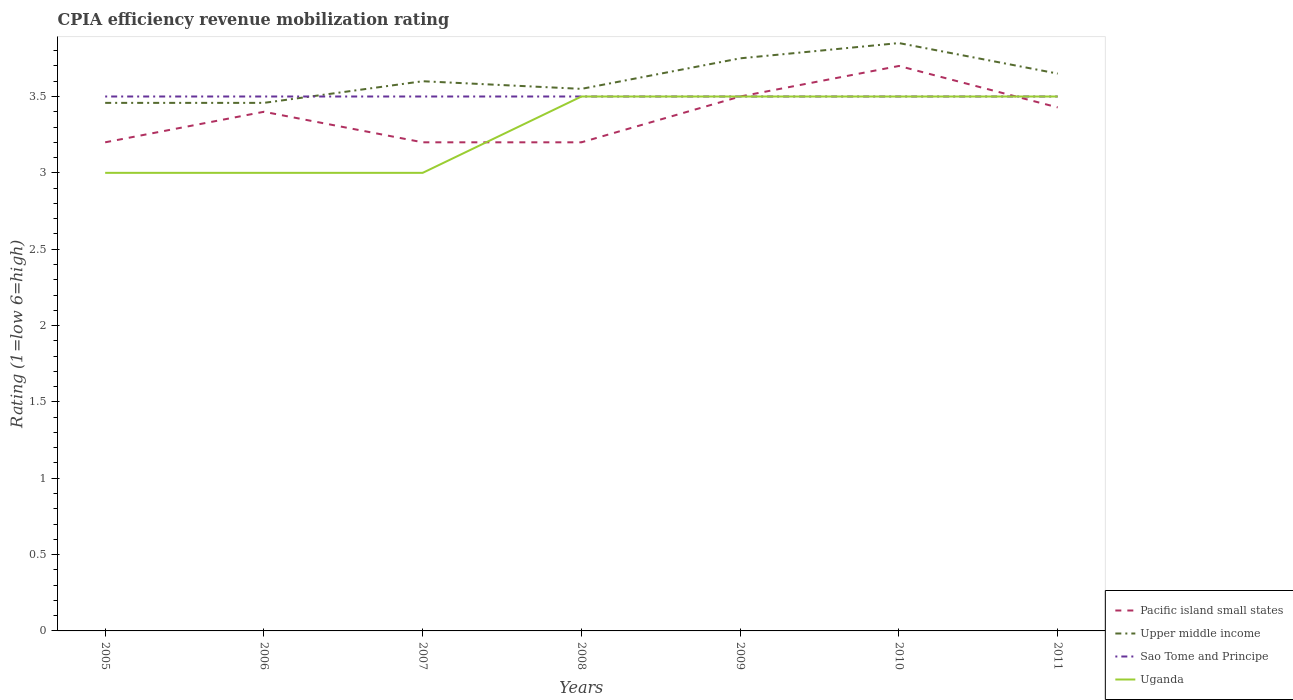Does the line corresponding to Uganda intersect with the line corresponding to Sao Tome and Principe?
Your answer should be compact. Yes. Is the number of lines equal to the number of legend labels?
Offer a very short reply. Yes. Across all years, what is the maximum CPIA rating in Upper middle income?
Provide a succinct answer. 3.46. In which year was the CPIA rating in Uganda maximum?
Your answer should be compact. 2005. What is the total CPIA rating in Sao Tome and Principe in the graph?
Offer a very short reply. 0. What is the difference between the highest and the second highest CPIA rating in Sao Tome and Principe?
Give a very brief answer. 0. Is the CPIA rating in Upper middle income strictly greater than the CPIA rating in Uganda over the years?
Ensure brevity in your answer.  No. How many lines are there?
Your response must be concise. 4. How many years are there in the graph?
Keep it short and to the point. 7. How many legend labels are there?
Give a very brief answer. 4. What is the title of the graph?
Make the answer very short. CPIA efficiency revenue mobilization rating. What is the label or title of the Y-axis?
Your answer should be very brief. Rating (1=low 6=high). What is the Rating (1=low 6=high) in Pacific island small states in 2005?
Provide a short and direct response. 3.2. What is the Rating (1=low 6=high) of Upper middle income in 2005?
Ensure brevity in your answer.  3.46. What is the Rating (1=low 6=high) in Upper middle income in 2006?
Your response must be concise. 3.46. What is the Rating (1=low 6=high) in Sao Tome and Principe in 2006?
Offer a very short reply. 3.5. What is the Rating (1=low 6=high) in Pacific island small states in 2007?
Offer a very short reply. 3.2. What is the Rating (1=low 6=high) in Sao Tome and Principe in 2007?
Ensure brevity in your answer.  3.5. What is the Rating (1=low 6=high) of Pacific island small states in 2008?
Give a very brief answer. 3.2. What is the Rating (1=low 6=high) in Upper middle income in 2008?
Keep it short and to the point. 3.55. What is the Rating (1=low 6=high) in Uganda in 2008?
Offer a very short reply. 3.5. What is the Rating (1=low 6=high) in Upper middle income in 2009?
Make the answer very short. 3.75. What is the Rating (1=low 6=high) of Sao Tome and Principe in 2009?
Give a very brief answer. 3.5. What is the Rating (1=low 6=high) of Upper middle income in 2010?
Offer a terse response. 3.85. What is the Rating (1=low 6=high) in Sao Tome and Principe in 2010?
Ensure brevity in your answer.  3.5. What is the Rating (1=low 6=high) of Pacific island small states in 2011?
Make the answer very short. 3.43. What is the Rating (1=low 6=high) of Upper middle income in 2011?
Keep it short and to the point. 3.65. What is the Rating (1=low 6=high) in Sao Tome and Principe in 2011?
Give a very brief answer. 3.5. What is the Rating (1=low 6=high) of Uganda in 2011?
Your answer should be very brief. 3.5. Across all years, what is the maximum Rating (1=low 6=high) of Upper middle income?
Offer a very short reply. 3.85. Across all years, what is the minimum Rating (1=low 6=high) in Pacific island small states?
Offer a very short reply. 3.2. Across all years, what is the minimum Rating (1=low 6=high) in Upper middle income?
Provide a short and direct response. 3.46. What is the total Rating (1=low 6=high) in Pacific island small states in the graph?
Offer a very short reply. 23.63. What is the total Rating (1=low 6=high) in Upper middle income in the graph?
Ensure brevity in your answer.  25.32. What is the total Rating (1=low 6=high) in Sao Tome and Principe in the graph?
Offer a very short reply. 24.5. What is the total Rating (1=low 6=high) of Uganda in the graph?
Your answer should be compact. 23. What is the difference between the Rating (1=low 6=high) in Upper middle income in 2005 and that in 2006?
Give a very brief answer. 0. What is the difference between the Rating (1=low 6=high) in Upper middle income in 2005 and that in 2007?
Offer a terse response. -0.14. What is the difference between the Rating (1=low 6=high) in Upper middle income in 2005 and that in 2008?
Make the answer very short. -0.09. What is the difference between the Rating (1=low 6=high) in Uganda in 2005 and that in 2008?
Make the answer very short. -0.5. What is the difference between the Rating (1=low 6=high) of Pacific island small states in 2005 and that in 2009?
Provide a short and direct response. -0.3. What is the difference between the Rating (1=low 6=high) in Upper middle income in 2005 and that in 2009?
Your answer should be compact. -0.29. What is the difference between the Rating (1=low 6=high) of Upper middle income in 2005 and that in 2010?
Your answer should be compact. -0.39. What is the difference between the Rating (1=low 6=high) in Sao Tome and Principe in 2005 and that in 2010?
Make the answer very short. 0. What is the difference between the Rating (1=low 6=high) of Pacific island small states in 2005 and that in 2011?
Give a very brief answer. -0.23. What is the difference between the Rating (1=low 6=high) in Upper middle income in 2005 and that in 2011?
Your answer should be very brief. -0.19. What is the difference between the Rating (1=low 6=high) in Upper middle income in 2006 and that in 2007?
Offer a very short reply. -0.14. What is the difference between the Rating (1=low 6=high) of Sao Tome and Principe in 2006 and that in 2007?
Keep it short and to the point. 0. What is the difference between the Rating (1=low 6=high) of Uganda in 2006 and that in 2007?
Offer a terse response. 0. What is the difference between the Rating (1=low 6=high) of Pacific island small states in 2006 and that in 2008?
Provide a succinct answer. 0.2. What is the difference between the Rating (1=low 6=high) in Upper middle income in 2006 and that in 2008?
Ensure brevity in your answer.  -0.09. What is the difference between the Rating (1=low 6=high) of Sao Tome and Principe in 2006 and that in 2008?
Offer a terse response. 0. What is the difference between the Rating (1=low 6=high) in Upper middle income in 2006 and that in 2009?
Your response must be concise. -0.29. What is the difference between the Rating (1=low 6=high) in Sao Tome and Principe in 2006 and that in 2009?
Your answer should be very brief. 0. What is the difference between the Rating (1=low 6=high) of Uganda in 2006 and that in 2009?
Your response must be concise. -0.5. What is the difference between the Rating (1=low 6=high) in Pacific island small states in 2006 and that in 2010?
Offer a very short reply. -0.3. What is the difference between the Rating (1=low 6=high) of Upper middle income in 2006 and that in 2010?
Offer a very short reply. -0.39. What is the difference between the Rating (1=low 6=high) in Sao Tome and Principe in 2006 and that in 2010?
Keep it short and to the point. 0. What is the difference between the Rating (1=low 6=high) in Uganda in 2006 and that in 2010?
Your response must be concise. -0.5. What is the difference between the Rating (1=low 6=high) of Pacific island small states in 2006 and that in 2011?
Ensure brevity in your answer.  -0.03. What is the difference between the Rating (1=low 6=high) of Upper middle income in 2006 and that in 2011?
Make the answer very short. -0.19. What is the difference between the Rating (1=low 6=high) of Sao Tome and Principe in 2006 and that in 2011?
Make the answer very short. 0. What is the difference between the Rating (1=low 6=high) in Pacific island small states in 2007 and that in 2009?
Make the answer very short. -0.3. What is the difference between the Rating (1=low 6=high) in Upper middle income in 2007 and that in 2009?
Make the answer very short. -0.15. What is the difference between the Rating (1=low 6=high) of Pacific island small states in 2007 and that in 2010?
Ensure brevity in your answer.  -0.5. What is the difference between the Rating (1=low 6=high) in Uganda in 2007 and that in 2010?
Ensure brevity in your answer.  -0.5. What is the difference between the Rating (1=low 6=high) in Pacific island small states in 2007 and that in 2011?
Keep it short and to the point. -0.23. What is the difference between the Rating (1=low 6=high) in Sao Tome and Principe in 2007 and that in 2011?
Provide a short and direct response. 0. What is the difference between the Rating (1=low 6=high) in Upper middle income in 2008 and that in 2009?
Provide a succinct answer. -0.2. What is the difference between the Rating (1=low 6=high) in Sao Tome and Principe in 2008 and that in 2009?
Your answer should be very brief. 0. What is the difference between the Rating (1=low 6=high) in Uganda in 2008 and that in 2009?
Provide a succinct answer. 0. What is the difference between the Rating (1=low 6=high) in Pacific island small states in 2008 and that in 2010?
Keep it short and to the point. -0.5. What is the difference between the Rating (1=low 6=high) in Sao Tome and Principe in 2008 and that in 2010?
Provide a short and direct response. 0. What is the difference between the Rating (1=low 6=high) in Pacific island small states in 2008 and that in 2011?
Make the answer very short. -0.23. What is the difference between the Rating (1=low 6=high) in Sao Tome and Principe in 2008 and that in 2011?
Your response must be concise. 0. What is the difference between the Rating (1=low 6=high) of Uganda in 2008 and that in 2011?
Provide a succinct answer. 0. What is the difference between the Rating (1=low 6=high) in Pacific island small states in 2009 and that in 2010?
Offer a terse response. -0.2. What is the difference between the Rating (1=low 6=high) of Sao Tome and Principe in 2009 and that in 2010?
Ensure brevity in your answer.  0. What is the difference between the Rating (1=low 6=high) in Pacific island small states in 2009 and that in 2011?
Offer a terse response. 0.07. What is the difference between the Rating (1=low 6=high) of Upper middle income in 2009 and that in 2011?
Offer a very short reply. 0.1. What is the difference between the Rating (1=low 6=high) in Sao Tome and Principe in 2009 and that in 2011?
Offer a terse response. 0. What is the difference between the Rating (1=low 6=high) of Pacific island small states in 2010 and that in 2011?
Give a very brief answer. 0.27. What is the difference between the Rating (1=low 6=high) of Upper middle income in 2010 and that in 2011?
Give a very brief answer. 0.2. What is the difference between the Rating (1=low 6=high) of Sao Tome and Principe in 2010 and that in 2011?
Offer a very short reply. 0. What is the difference between the Rating (1=low 6=high) of Pacific island small states in 2005 and the Rating (1=low 6=high) of Upper middle income in 2006?
Ensure brevity in your answer.  -0.26. What is the difference between the Rating (1=low 6=high) in Upper middle income in 2005 and the Rating (1=low 6=high) in Sao Tome and Principe in 2006?
Offer a terse response. -0.04. What is the difference between the Rating (1=low 6=high) of Upper middle income in 2005 and the Rating (1=low 6=high) of Uganda in 2006?
Ensure brevity in your answer.  0.46. What is the difference between the Rating (1=low 6=high) of Sao Tome and Principe in 2005 and the Rating (1=low 6=high) of Uganda in 2006?
Keep it short and to the point. 0.5. What is the difference between the Rating (1=low 6=high) of Pacific island small states in 2005 and the Rating (1=low 6=high) of Upper middle income in 2007?
Offer a terse response. -0.4. What is the difference between the Rating (1=low 6=high) in Pacific island small states in 2005 and the Rating (1=low 6=high) in Sao Tome and Principe in 2007?
Keep it short and to the point. -0.3. What is the difference between the Rating (1=low 6=high) in Upper middle income in 2005 and the Rating (1=low 6=high) in Sao Tome and Principe in 2007?
Provide a short and direct response. -0.04. What is the difference between the Rating (1=low 6=high) in Upper middle income in 2005 and the Rating (1=low 6=high) in Uganda in 2007?
Make the answer very short. 0.46. What is the difference between the Rating (1=low 6=high) of Pacific island small states in 2005 and the Rating (1=low 6=high) of Upper middle income in 2008?
Provide a short and direct response. -0.35. What is the difference between the Rating (1=low 6=high) of Upper middle income in 2005 and the Rating (1=low 6=high) of Sao Tome and Principe in 2008?
Provide a short and direct response. -0.04. What is the difference between the Rating (1=low 6=high) of Upper middle income in 2005 and the Rating (1=low 6=high) of Uganda in 2008?
Provide a short and direct response. -0.04. What is the difference between the Rating (1=low 6=high) of Pacific island small states in 2005 and the Rating (1=low 6=high) of Upper middle income in 2009?
Your response must be concise. -0.55. What is the difference between the Rating (1=low 6=high) of Pacific island small states in 2005 and the Rating (1=low 6=high) of Sao Tome and Principe in 2009?
Your answer should be very brief. -0.3. What is the difference between the Rating (1=low 6=high) of Upper middle income in 2005 and the Rating (1=low 6=high) of Sao Tome and Principe in 2009?
Give a very brief answer. -0.04. What is the difference between the Rating (1=low 6=high) of Upper middle income in 2005 and the Rating (1=low 6=high) of Uganda in 2009?
Provide a succinct answer. -0.04. What is the difference between the Rating (1=low 6=high) in Pacific island small states in 2005 and the Rating (1=low 6=high) in Upper middle income in 2010?
Your response must be concise. -0.65. What is the difference between the Rating (1=low 6=high) in Pacific island small states in 2005 and the Rating (1=low 6=high) in Uganda in 2010?
Offer a terse response. -0.3. What is the difference between the Rating (1=low 6=high) of Upper middle income in 2005 and the Rating (1=low 6=high) of Sao Tome and Principe in 2010?
Give a very brief answer. -0.04. What is the difference between the Rating (1=low 6=high) of Upper middle income in 2005 and the Rating (1=low 6=high) of Uganda in 2010?
Your answer should be very brief. -0.04. What is the difference between the Rating (1=low 6=high) of Sao Tome and Principe in 2005 and the Rating (1=low 6=high) of Uganda in 2010?
Your response must be concise. 0. What is the difference between the Rating (1=low 6=high) of Pacific island small states in 2005 and the Rating (1=low 6=high) of Upper middle income in 2011?
Provide a succinct answer. -0.45. What is the difference between the Rating (1=low 6=high) of Pacific island small states in 2005 and the Rating (1=low 6=high) of Sao Tome and Principe in 2011?
Provide a succinct answer. -0.3. What is the difference between the Rating (1=low 6=high) of Upper middle income in 2005 and the Rating (1=low 6=high) of Sao Tome and Principe in 2011?
Your answer should be compact. -0.04. What is the difference between the Rating (1=low 6=high) in Upper middle income in 2005 and the Rating (1=low 6=high) in Uganda in 2011?
Give a very brief answer. -0.04. What is the difference between the Rating (1=low 6=high) in Sao Tome and Principe in 2005 and the Rating (1=low 6=high) in Uganda in 2011?
Give a very brief answer. 0. What is the difference between the Rating (1=low 6=high) of Pacific island small states in 2006 and the Rating (1=low 6=high) of Sao Tome and Principe in 2007?
Your answer should be very brief. -0.1. What is the difference between the Rating (1=low 6=high) in Upper middle income in 2006 and the Rating (1=low 6=high) in Sao Tome and Principe in 2007?
Keep it short and to the point. -0.04. What is the difference between the Rating (1=low 6=high) in Upper middle income in 2006 and the Rating (1=low 6=high) in Uganda in 2007?
Provide a short and direct response. 0.46. What is the difference between the Rating (1=low 6=high) of Sao Tome and Principe in 2006 and the Rating (1=low 6=high) of Uganda in 2007?
Your answer should be compact. 0.5. What is the difference between the Rating (1=low 6=high) of Upper middle income in 2006 and the Rating (1=low 6=high) of Sao Tome and Principe in 2008?
Your answer should be compact. -0.04. What is the difference between the Rating (1=low 6=high) of Upper middle income in 2006 and the Rating (1=low 6=high) of Uganda in 2008?
Your response must be concise. -0.04. What is the difference between the Rating (1=low 6=high) of Sao Tome and Principe in 2006 and the Rating (1=low 6=high) of Uganda in 2008?
Your response must be concise. 0. What is the difference between the Rating (1=low 6=high) of Pacific island small states in 2006 and the Rating (1=low 6=high) of Upper middle income in 2009?
Ensure brevity in your answer.  -0.35. What is the difference between the Rating (1=low 6=high) of Pacific island small states in 2006 and the Rating (1=low 6=high) of Uganda in 2009?
Provide a short and direct response. -0.1. What is the difference between the Rating (1=low 6=high) in Upper middle income in 2006 and the Rating (1=low 6=high) in Sao Tome and Principe in 2009?
Offer a very short reply. -0.04. What is the difference between the Rating (1=low 6=high) in Upper middle income in 2006 and the Rating (1=low 6=high) in Uganda in 2009?
Your response must be concise. -0.04. What is the difference between the Rating (1=low 6=high) in Sao Tome and Principe in 2006 and the Rating (1=low 6=high) in Uganda in 2009?
Your answer should be compact. 0. What is the difference between the Rating (1=low 6=high) of Pacific island small states in 2006 and the Rating (1=low 6=high) of Upper middle income in 2010?
Your response must be concise. -0.45. What is the difference between the Rating (1=low 6=high) in Pacific island small states in 2006 and the Rating (1=low 6=high) in Sao Tome and Principe in 2010?
Provide a succinct answer. -0.1. What is the difference between the Rating (1=low 6=high) of Pacific island small states in 2006 and the Rating (1=low 6=high) of Uganda in 2010?
Provide a succinct answer. -0.1. What is the difference between the Rating (1=low 6=high) of Upper middle income in 2006 and the Rating (1=low 6=high) of Sao Tome and Principe in 2010?
Provide a succinct answer. -0.04. What is the difference between the Rating (1=low 6=high) of Upper middle income in 2006 and the Rating (1=low 6=high) of Uganda in 2010?
Keep it short and to the point. -0.04. What is the difference between the Rating (1=low 6=high) in Pacific island small states in 2006 and the Rating (1=low 6=high) in Uganda in 2011?
Give a very brief answer. -0.1. What is the difference between the Rating (1=low 6=high) in Upper middle income in 2006 and the Rating (1=low 6=high) in Sao Tome and Principe in 2011?
Provide a succinct answer. -0.04. What is the difference between the Rating (1=low 6=high) of Upper middle income in 2006 and the Rating (1=low 6=high) of Uganda in 2011?
Give a very brief answer. -0.04. What is the difference between the Rating (1=low 6=high) in Pacific island small states in 2007 and the Rating (1=low 6=high) in Upper middle income in 2008?
Make the answer very short. -0.35. What is the difference between the Rating (1=low 6=high) in Pacific island small states in 2007 and the Rating (1=low 6=high) in Sao Tome and Principe in 2008?
Give a very brief answer. -0.3. What is the difference between the Rating (1=low 6=high) in Upper middle income in 2007 and the Rating (1=low 6=high) in Sao Tome and Principe in 2008?
Your answer should be very brief. 0.1. What is the difference between the Rating (1=low 6=high) in Upper middle income in 2007 and the Rating (1=low 6=high) in Uganda in 2008?
Your answer should be compact. 0.1. What is the difference between the Rating (1=low 6=high) in Sao Tome and Principe in 2007 and the Rating (1=low 6=high) in Uganda in 2008?
Your response must be concise. 0. What is the difference between the Rating (1=low 6=high) of Pacific island small states in 2007 and the Rating (1=low 6=high) of Upper middle income in 2009?
Your answer should be compact. -0.55. What is the difference between the Rating (1=low 6=high) in Pacific island small states in 2007 and the Rating (1=low 6=high) in Upper middle income in 2010?
Provide a succinct answer. -0.65. What is the difference between the Rating (1=low 6=high) of Upper middle income in 2007 and the Rating (1=low 6=high) of Sao Tome and Principe in 2010?
Offer a very short reply. 0.1. What is the difference between the Rating (1=low 6=high) in Upper middle income in 2007 and the Rating (1=low 6=high) in Uganda in 2010?
Make the answer very short. 0.1. What is the difference between the Rating (1=low 6=high) of Pacific island small states in 2007 and the Rating (1=low 6=high) of Upper middle income in 2011?
Offer a terse response. -0.45. What is the difference between the Rating (1=low 6=high) of Pacific island small states in 2007 and the Rating (1=low 6=high) of Sao Tome and Principe in 2011?
Make the answer very short. -0.3. What is the difference between the Rating (1=low 6=high) in Sao Tome and Principe in 2007 and the Rating (1=low 6=high) in Uganda in 2011?
Make the answer very short. 0. What is the difference between the Rating (1=low 6=high) in Pacific island small states in 2008 and the Rating (1=low 6=high) in Upper middle income in 2009?
Make the answer very short. -0.55. What is the difference between the Rating (1=low 6=high) of Pacific island small states in 2008 and the Rating (1=low 6=high) of Sao Tome and Principe in 2009?
Keep it short and to the point. -0.3. What is the difference between the Rating (1=low 6=high) of Upper middle income in 2008 and the Rating (1=low 6=high) of Sao Tome and Principe in 2009?
Offer a terse response. 0.05. What is the difference between the Rating (1=low 6=high) of Upper middle income in 2008 and the Rating (1=low 6=high) of Uganda in 2009?
Ensure brevity in your answer.  0.05. What is the difference between the Rating (1=low 6=high) in Sao Tome and Principe in 2008 and the Rating (1=low 6=high) in Uganda in 2009?
Your response must be concise. 0. What is the difference between the Rating (1=low 6=high) in Pacific island small states in 2008 and the Rating (1=low 6=high) in Upper middle income in 2010?
Ensure brevity in your answer.  -0.65. What is the difference between the Rating (1=low 6=high) of Pacific island small states in 2008 and the Rating (1=low 6=high) of Sao Tome and Principe in 2010?
Provide a succinct answer. -0.3. What is the difference between the Rating (1=low 6=high) in Pacific island small states in 2008 and the Rating (1=low 6=high) in Upper middle income in 2011?
Your answer should be compact. -0.45. What is the difference between the Rating (1=low 6=high) of Pacific island small states in 2008 and the Rating (1=low 6=high) of Sao Tome and Principe in 2011?
Make the answer very short. -0.3. What is the difference between the Rating (1=low 6=high) in Pacific island small states in 2008 and the Rating (1=low 6=high) in Uganda in 2011?
Your answer should be compact. -0.3. What is the difference between the Rating (1=low 6=high) of Pacific island small states in 2009 and the Rating (1=low 6=high) of Upper middle income in 2010?
Keep it short and to the point. -0.35. What is the difference between the Rating (1=low 6=high) of Pacific island small states in 2009 and the Rating (1=low 6=high) of Uganda in 2010?
Keep it short and to the point. 0. What is the difference between the Rating (1=low 6=high) of Upper middle income in 2009 and the Rating (1=low 6=high) of Uganda in 2010?
Your response must be concise. 0.25. What is the difference between the Rating (1=low 6=high) of Pacific island small states in 2009 and the Rating (1=low 6=high) of Upper middle income in 2011?
Your response must be concise. -0.15. What is the difference between the Rating (1=low 6=high) of Pacific island small states in 2009 and the Rating (1=low 6=high) of Sao Tome and Principe in 2011?
Provide a short and direct response. 0. What is the difference between the Rating (1=low 6=high) in Pacific island small states in 2009 and the Rating (1=low 6=high) in Uganda in 2011?
Offer a terse response. 0. What is the difference between the Rating (1=low 6=high) in Pacific island small states in 2010 and the Rating (1=low 6=high) in Upper middle income in 2011?
Provide a short and direct response. 0.05. What is the average Rating (1=low 6=high) in Pacific island small states per year?
Make the answer very short. 3.38. What is the average Rating (1=low 6=high) in Upper middle income per year?
Provide a succinct answer. 3.62. What is the average Rating (1=low 6=high) of Sao Tome and Principe per year?
Give a very brief answer. 3.5. What is the average Rating (1=low 6=high) of Uganda per year?
Your answer should be compact. 3.29. In the year 2005, what is the difference between the Rating (1=low 6=high) in Pacific island small states and Rating (1=low 6=high) in Upper middle income?
Your response must be concise. -0.26. In the year 2005, what is the difference between the Rating (1=low 6=high) in Pacific island small states and Rating (1=low 6=high) in Uganda?
Make the answer very short. 0.2. In the year 2005, what is the difference between the Rating (1=low 6=high) of Upper middle income and Rating (1=low 6=high) of Sao Tome and Principe?
Keep it short and to the point. -0.04. In the year 2005, what is the difference between the Rating (1=low 6=high) of Upper middle income and Rating (1=low 6=high) of Uganda?
Keep it short and to the point. 0.46. In the year 2005, what is the difference between the Rating (1=low 6=high) in Sao Tome and Principe and Rating (1=low 6=high) in Uganda?
Keep it short and to the point. 0.5. In the year 2006, what is the difference between the Rating (1=low 6=high) in Pacific island small states and Rating (1=low 6=high) in Upper middle income?
Give a very brief answer. -0.06. In the year 2006, what is the difference between the Rating (1=low 6=high) of Upper middle income and Rating (1=low 6=high) of Sao Tome and Principe?
Keep it short and to the point. -0.04. In the year 2006, what is the difference between the Rating (1=low 6=high) of Upper middle income and Rating (1=low 6=high) of Uganda?
Provide a succinct answer. 0.46. In the year 2007, what is the difference between the Rating (1=low 6=high) of Pacific island small states and Rating (1=low 6=high) of Sao Tome and Principe?
Offer a terse response. -0.3. In the year 2007, what is the difference between the Rating (1=low 6=high) in Pacific island small states and Rating (1=low 6=high) in Uganda?
Offer a very short reply. 0.2. In the year 2007, what is the difference between the Rating (1=low 6=high) in Upper middle income and Rating (1=low 6=high) in Sao Tome and Principe?
Keep it short and to the point. 0.1. In the year 2008, what is the difference between the Rating (1=low 6=high) of Pacific island small states and Rating (1=low 6=high) of Upper middle income?
Provide a short and direct response. -0.35. In the year 2008, what is the difference between the Rating (1=low 6=high) in Pacific island small states and Rating (1=low 6=high) in Uganda?
Keep it short and to the point. -0.3. In the year 2008, what is the difference between the Rating (1=low 6=high) of Upper middle income and Rating (1=low 6=high) of Uganda?
Your answer should be very brief. 0.05. In the year 2008, what is the difference between the Rating (1=low 6=high) in Sao Tome and Principe and Rating (1=low 6=high) in Uganda?
Make the answer very short. 0. In the year 2009, what is the difference between the Rating (1=low 6=high) of Pacific island small states and Rating (1=low 6=high) of Upper middle income?
Provide a succinct answer. -0.25. In the year 2009, what is the difference between the Rating (1=low 6=high) in Sao Tome and Principe and Rating (1=low 6=high) in Uganda?
Keep it short and to the point. 0. In the year 2010, what is the difference between the Rating (1=low 6=high) in Pacific island small states and Rating (1=low 6=high) in Upper middle income?
Ensure brevity in your answer.  -0.15. In the year 2010, what is the difference between the Rating (1=low 6=high) in Pacific island small states and Rating (1=low 6=high) in Sao Tome and Principe?
Keep it short and to the point. 0.2. In the year 2010, what is the difference between the Rating (1=low 6=high) in Upper middle income and Rating (1=low 6=high) in Sao Tome and Principe?
Your answer should be very brief. 0.35. In the year 2010, what is the difference between the Rating (1=low 6=high) of Sao Tome and Principe and Rating (1=low 6=high) of Uganda?
Your answer should be compact. 0. In the year 2011, what is the difference between the Rating (1=low 6=high) of Pacific island small states and Rating (1=low 6=high) of Upper middle income?
Make the answer very short. -0.22. In the year 2011, what is the difference between the Rating (1=low 6=high) of Pacific island small states and Rating (1=low 6=high) of Sao Tome and Principe?
Ensure brevity in your answer.  -0.07. In the year 2011, what is the difference between the Rating (1=low 6=high) of Pacific island small states and Rating (1=low 6=high) of Uganda?
Ensure brevity in your answer.  -0.07. In the year 2011, what is the difference between the Rating (1=low 6=high) of Upper middle income and Rating (1=low 6=high) of Sao Tome and Principe?
Offer a terse response. 0.15. In the year 2011, what is the difference between the Rating (1=low 6=high) in Upper middle income and Rating (1=low 6=high) in Uganda?
Ensure brevity in your answer.  0.15. In the year 2011, what is the difference between the Rating (1=low 6=high) of Sao Tome and Principe and Rating (1=low 6=high) of Uganda?
Offer a very short reply. 0. What is the ratio of the Rating (1=low 6=high) in Pacific island small states in 2005 to that in 2006?
Ensure brevity in your answer.  0.94. What is the ratio of the Rating (1=low 6=high) of Sao Tome and Principe in 2005 to that in 2006?
Offer a terse response. 1. What is the ratio of the Rating (1=low 6=high) of Upper middle income in 2005 to that in 2007?
Ensure brevity in your answer.  0.96. What is the ratio of the Rating (1=low 6=high) in Sao Tome and Principe in 2005 to that in 2007?
Keep it short and to the point. 1. What is the ratio of the Rating (1=low 6=high) of Uganda in 2005 to that in 2007?
Provide a succinct answer. 1. What is the ratio of the Rating (1=low 6=high) in Upper middle income in 2005 to that in 2008?
Your answer should be compact. 0.97. What is the ratio of the Rating (1=low 6=high) of Pacific island small states in 2005 to that in 2009?
Keep it short and to the point. 0.91. What is the ratio of the Rating (1=low 6=high) of Upper middle income in 2005 to that in 2009?
Offer a very short reply. 0.92. What is the ratio of the Rating (1=low 6=high) of Sao Tome and Principe in 2005 to that in 2009?
Your response must be concise. 1. What is the ratio of the Rating (1=low 6=high) of Uganda in 2005 to that in 2009?
Offer a very short reply. 0.86. What is the ratio of the Rating (1=low 6=high) of Pacific island small states in 2005 to that in 2010?
Give a very brief answer. 0.86. What is the ratio of the Rating (1=low 6=high) of Upper middle income in 2005 to that in 2010?
Make the answer very short. 0.9. What is the ratio of the Rating (1=low 6=high) of Sao Tome and Principe in 2005 to that in 2010?
Your response must be concise. 1. What is the ratio of the Rating (1=low 6=high) in Uganda in 2005 to that in 2010?
Provide a short and direct response. 0.86. What is the ratio of the Rating (1=low 6=high) in Upper middle income in 2005 to that in 2011?
Offer a terse response. 0.95. What is the ratio of the Rating (1=low 6=high) in Sao Tome and Principe in 2005 to that in 2011?
Provide a short and direct response. 1. What is the ratio of the Rating (1=low 6=high) in Uganda in 2005 to that in 2011?
Provide a succinct answer. 0.86. What is the ratio of the Rating (1=low 6=high) of Pacific island small states in 2006 to that in 2007?
Your answer should be compact. 1.06. What is the ratio of the Rating (1=low 6=high) in Upper middle income in 2006 to that in 2007?
Make the answer very short. 0.96. What is the ratio of the Rating (1=low 6=high) of Sao Tome and Principe in 2006 to that in 2007?
Provide a succinct answer. 1. What is the ratio of the Rating (1=low 6=high) of Uganda in 2006 to that in 2007?
Give a very brief answer. 1. What is the ratio of the Rating (1=low 6=high) in Pacific island small states in 2006 to that in 2008?
Offer a terse response. 1.06. What is the ratio of the Rating (1=low 6=high) in Upper middle income in 2006 to that in 2008?
Give a very brief answer. 0.97. What is the ratio of the Rating (1=low 6=high) of Pacific island small states in 2006 to that in 2009?
Ensure brevity in your answer.  0.97. What is the ratio of the Rating (1=low 6=high) of Upper middle income in 2006 to that in 2009?
Offer a terse response. 0.92. What is the ratio of the Rating (1=low 6=high) of Pacific island small states in 2006 to that in 2010?
Ensure brevity in your answer.  0.92. What is the ratio of the Rating (1=low 6=high) in Upper middle income in 2006 to that in 2010?
Offer a very short reply. 0.9. What is the ratio of the Rating (1=low 6=high) in Sao Tome and Principe in 2006 to that in 2010?
Your answer should be compact. 1. What is the ratio of the Rating (1=low 6=high) of Pacific island small states in 2006 to that in 2011?
Your answer should be compact. 0.99. What is the ratio of the Rating (1=low 6=high) in Upper middle income in 2006 to that in 2011?
Your answer should be compact. 0.95. What is the ratio of the Rating (1=low 6=high) of Pacific island small states in 2007 to that in 2008?
Provide a succinct answer. 1. What is the ratio of the Rating (1=low 6=high) of Upper middle income in 2007 to that in 2008?
Your answer should be very brief. 1.01. What is the ratio of the Rating (1=low 6=high) of Uganda in 2007 to that in 2008?
Provide a short and direct response. 0.86. What is the ratio of the Rating (1=low 6=high) of Pacific island small states in 2007 to that in 2009?
Offer a very short reply. 0.91. What is the ratio of the Rating (1=low 6=high) of Pacific island small states in 2007 to that in 2010?
Provide a short and direct response. 0.86. What is the ratio of the Rating (1=low 6=high) of Upper middle income in 2007 to that in 2010?
Give a very brief answer. 0.94. What is the ratio of the Rating (1=low 6=high) of Pacific island small states in 2007 to that in 2011?
Offer a terse response. 0.93. What is the ratio of the Rating (1=low 6=high) in Upper middle income in 2007 to that in 2011?
Your answer should be compact. 0.99. What is the ratio of the Rating (1=low 6=high) in Uganda in 2007 to that in 2011?
Provide a succinct answer. 0.86. What is the ratio of the Rating (1=low 6=high) in Pacific island small states in 2008 to that in 2009?
Make the answer very short. 0.91. What is the ratio of the Rating (1=low 6=high) in Upper middle income in 2008 to that in 2009?
Your response must be concise. 0.95. What is the ratio of the Rating (1=low 6=high) of Uganda in 2008 to that in 2009?
Give a very brief answer. 1. What is the ratio of the Rating (1=low 6=high) of Pacific island small states in 2008 to that in 2010?
Offer a very short reply. 0.86. What is the ratio of the Rating (1=low 6=high) in Upper middle income in 2008 to that in 2010?
Your answer should be compact. 0.92. What is the ratio of the Rating (1=low 6=high) of Sao Tome and Principe in 2008 to that in 2010?
Keep it short and to the point. 1. What is the ratio of the Rating (1=low 6=high) of Pacific island small states in 2008 to that in 2011?
Ensure brevity in your answer.  0.93. What is the ratio of the Rating (1=low 6=high) in Upper middle income in 2008 to that in 2011?
Offer a very short reply. 0.97. What is the ratio of the Rating (1=low 6=high) in Uganda in 2008 to that in 2011?
Make the answer very short. 1. What is the ratio of the Rating (1=low 6=high) of Pacific island small states in 2009 to that in 2010?
Give a very brief answer. 0.95. What is the ratio of the Rating (1=low 6=high) in Upper middle income in 2009 to that in 2010?
Ensure brevity in your answer.  0.97. What is the ratio of the Rating (1=low 6=high) in Pacific island small states in 2009 to that in 2011?
Provide a succinct answer. 1.02. What is the ratio of the Rating (1=low 6=high) of Upper middle income in 2009 to that in 2011?
Your answer should be very brief. 1.03. What is the ratio of the Rating (1=low 6=high) of Pacific island small states in 2010 to that in 2011?
Make the answer very short. 1.08. What is the ratio of the Rating (1=low 6=high) of Upper middle income in 2010 to that in 2011?
Make the answer very short. 1.05. What is the difference between the highest and the second highest Rating (1=low 6=high) of Upper middle income?
Make the answer very short. 0.1. What is the difference between the highest and the second highest Rating (1=low 6=high) in Sao Tome and Principe?
Give a very brief answer. 0. What is the difference between the highest and the lowest Rating (1=low 6=high) in Upper middle income?
Your answer should be compact. 0.39. 